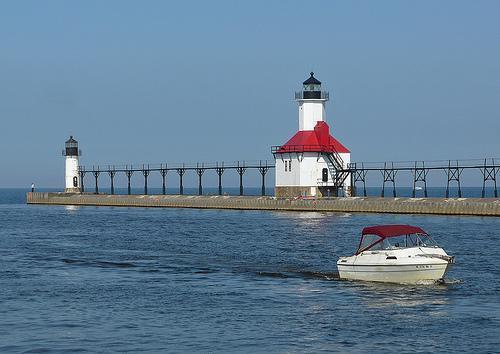How many boats are in a picture?
Give a very brief answer. 1. How many boats are in the photo?
Give a very brief answer. 1. How many lighthouses are there?
Give a very brief answer. 2. 